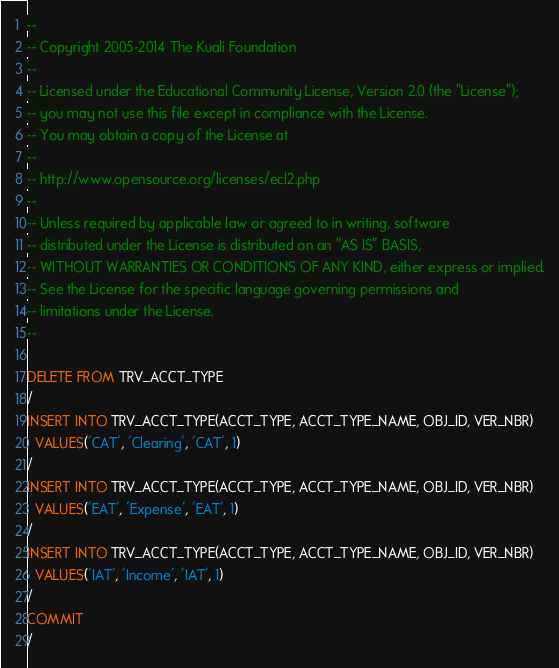Convert code to text. <code><loc_0><loc_0><loc_500><loc_500><_SQL_>--
-- Copyright 2005-2014 The Kuali Foundation
--
-- Licensed under the Educational Community License, Version 2.0 (the "License");
-- you may not use this file except in compliance with the License.
-- You may obtain a copy of the License at
--
-- http://www.opensource.org/licenses/ecl2.php
--
-- Unless required by applicable law or agreed to in writing, software
-- distributed under the License is distributed on an "AS IS" BASIS,
-- WITHOUT WARRANTIES OR CONDITIONS OF ANY KIND, either express or implied.
-- See the License for the specific language governing permissions and
-- limitations under the License.
--

DELETE FROM TRV_ACCT_TYPE
/
INSERT INTO TRV_ACCT_TYPE(ACCT_TYPE, ACCT_TYPE_NAME, OBJ_ID, VER_NBR)
  VALUES('CAT', 'Clearing', 'CAT', 1)
/
INSERT INTO TRV_ACCT_TYPE(ACCT_TYPE, ACCT_TYPE_NAME, OBJ_ID, VER_NBR)
  VALUES('EAT', 'Expense', 'EAT', 1)
/
INSERT INTO TRV_ACCT_TYPE(ACCT_TYPE, ACCT_TYPE_NAME, OBJ_ID, VER_NBR)
  VALUES('IAT', 'Income', 'IAT', 1)
/
COMMIT
/
</code> 